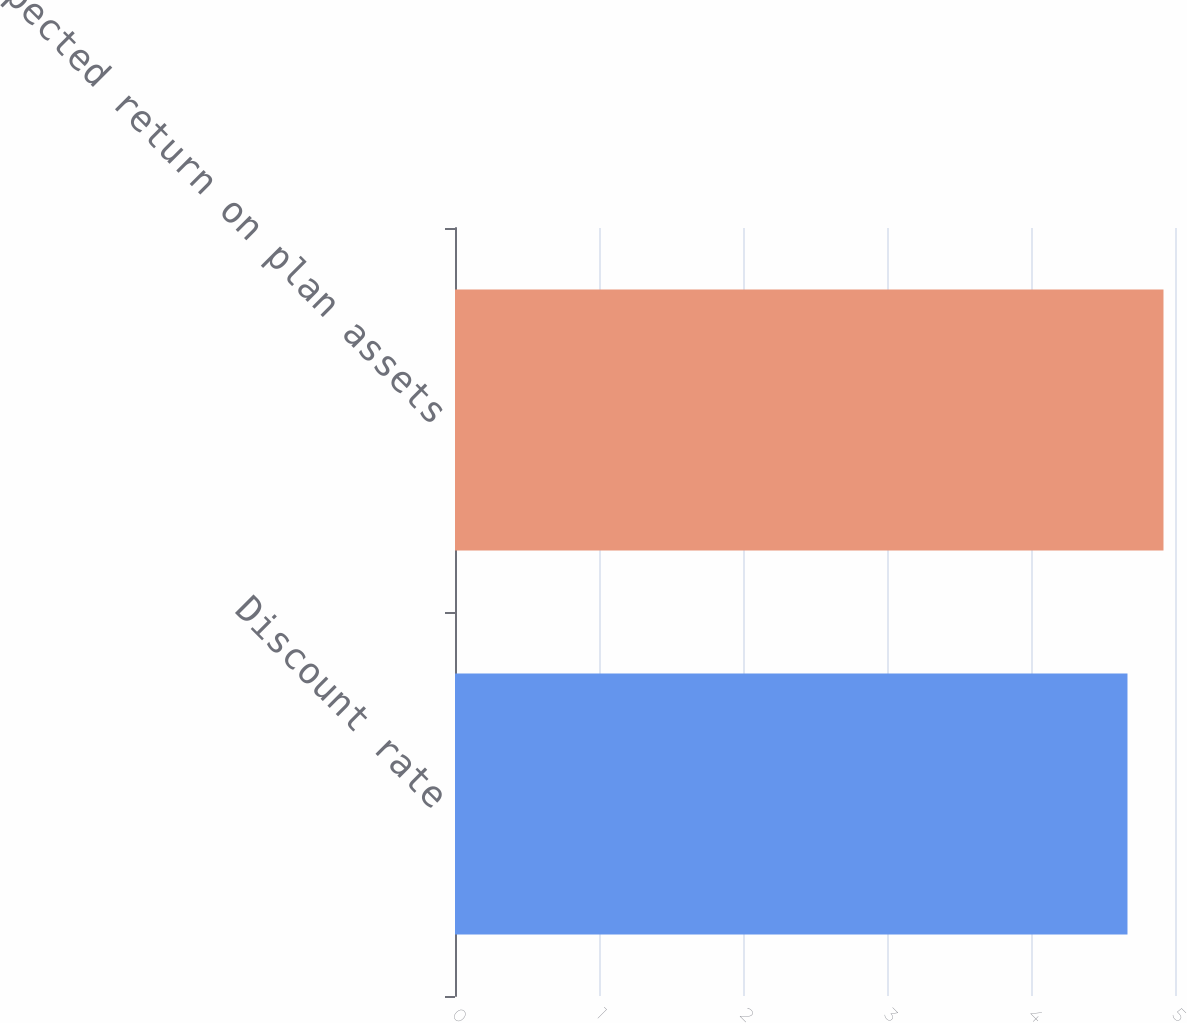<chart> <loc_0><loc_0><loc_500><loc_500><bar_chart><fcel>Discount rate<fcel>Expected return on plan assets<nl><fcel>4.67<fcel>4.92<nl></chart> 